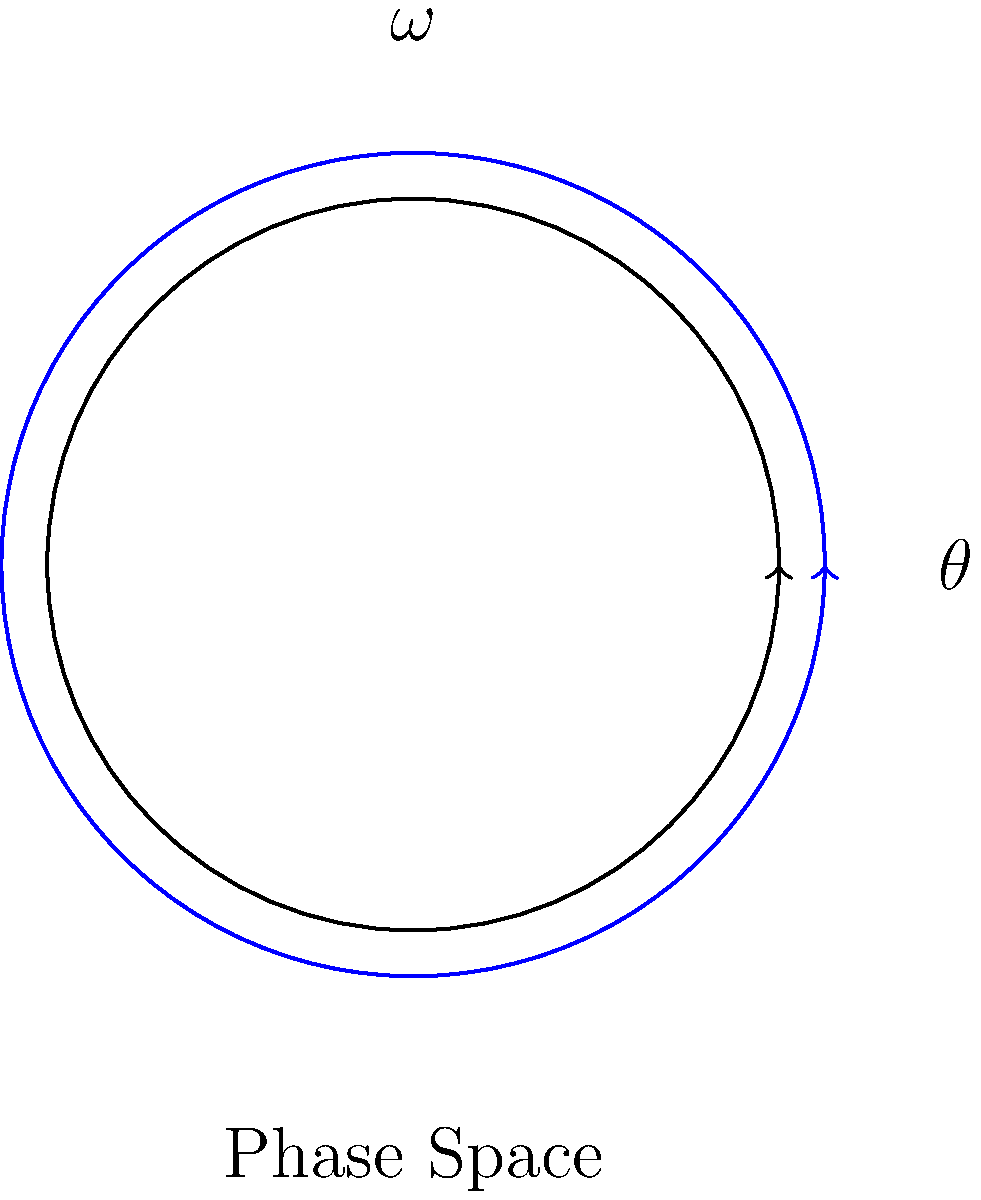In the context of chaotic systems, consider a simple pendulum undergoing circular motion. The phase space diagram above represents the pendulum's motion, where $\theta$ is the angular position and $\omega$ is the angular velocity. What does the closed loop trajectory (blue) in this phase space indicate about the pendulum's motion, and how might this relate to the concept of attractors in chaotic systems? To understand the relationship between circular motion and phase space trajectories in chaotic systems, let's analyze this step-by-step:

1. Phase space representation:
   - The phase space diagram shows the relationship between position ($\theta$) and velocity ($\omega$) of the pendulum.
   - Each point on the trajectory represents a unique state of the system.

2. Closed loop trajectory:
   - The blue curve forms a closed loop in the phase space.
   - This indicates that the motion is periodic, repeating the same states over time.

3. Interpretation of periodic motion:
   - For a simple pendulum, this closed loop suggests simple harmonic motion.
   - The pendulum swings back and forth with a constant amplitude and frequency.

4. Relation to chaotic systems:
   - In contrast, chaotic systems typically show non-repeating trajectories in phase space.
   - These trajectories often form complex structures called strange attractors.

5. Attractors in chaotic systems:
   - An attractor is a set of states toward which a system tends to evolve.
   - For this simple pendulum, the closed loop itself is an attractor (specifically, a limit cycle).
   - In chaotic systems, attractors can have fractal structures (strange attractors).

6. Transition to chaos:
   - As system parameters change (e.g., adding damping or driving forces), the simple closed loop can bifurcate.
   - This can lead to more complex trajectories and eventually chaos.

7. Statistical modeling implications:
   - The regularity of this trajectory allows for straightforward statistical predictions.
   - In chaotic systems, the unpredictability of trajectories necessitates more advanced statistical approaches, such as ergodic theory or Poincaré recurrence statistics.
Answer: Periodic motion; limit cycle attractor 